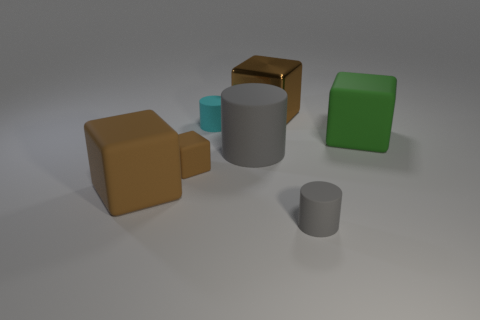There is a rubber thing that is both in front of the big gray thing and right of the large matte cylinder; what size is it?
Your answer should be very brief. Small. There is a tiny rubber thing that is the same shape as the metallic object; what is its color?
Ensure brevity in your answer.  Brown. What color is the big object behind the tiny cylinder behind the tiny brown object?
Your answer should be compact. Brown. The cyan rubber thing has what shape?
Your response must be concise. Cylinder. What shape is the large matte thing that is behind the tiny brown rubber thing and on the left side of the tiny gray rubber cylinder?
Offer a terse response. Cylinder. What is the color of the tiny cube that is made of the same material as the green object?
Keep it short and to the point. Brown. There is a small matte object right of the tiny cyan object to the left of the tiny cylinder in front of the big green block; what shape is it?
Provide a succinct answer. Cylinder. How big is the cyan cylinder?
Ensure brevity in your answer.  Small. The gray object that is the same material as the big gray cylinder is what shape?
Your response must be concise. Cylinder. Are there fewer small gray matte objects left of the tiny brown object than tiny gray matte balls?
Your answer should be very brief. No. 